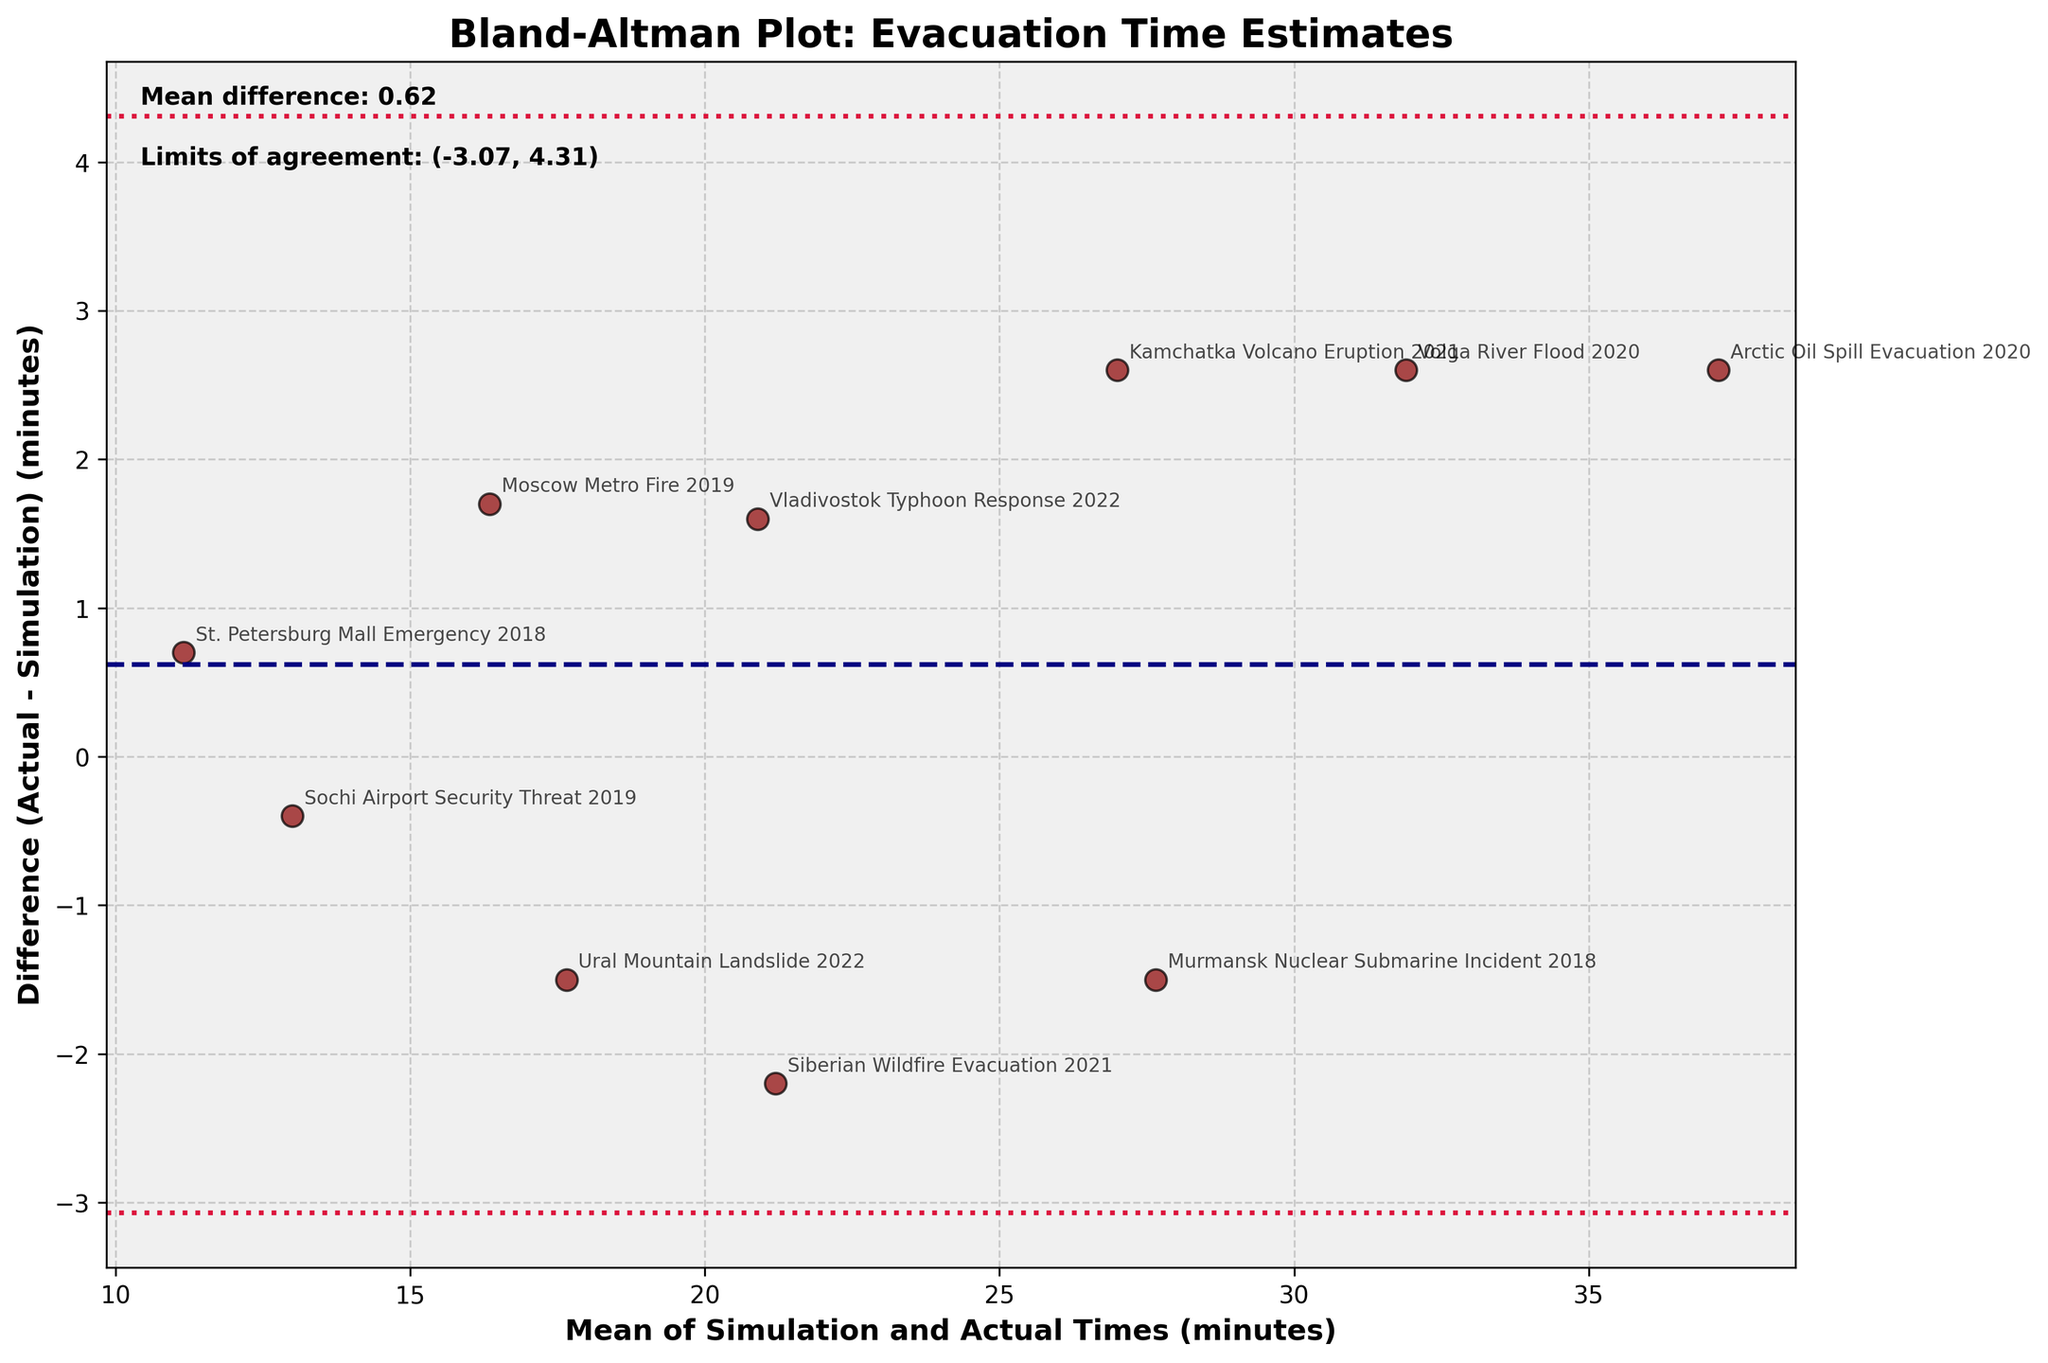What's the title of the figure? The title of a figure is usually found at the top and is bolded to stand out. In this case, the title "Bland-Altman Plot: Evacuation Time Estimates" is clearly displayed at the top of the plot.
Answer: Bland-Altman Plot: Evacuation Time Estimates How many events are plotted in the figure? Count each data point that is plotted in the Bland-Altman plot. Each represents an event. There are 10 data points in the plot.
Answer: 10 What are the x-axis and y-axis labels of the plot? The axis labels are found on the horizontal and vertical axes. The x-axis is labeled "Mean of Simulation and Actual Times (minutes)." The y-axis is labeled "Difference (Actual - Simulation) (minutes)."
Answer: Mean of Simulation and Actual Times (minutes) and Difference (Actual - Simulation) (minutes) What is the mean difference in evacuation times? The mean difference is displayed as text within the plot. It says "Mean difference: 1.28" on the top-left corner of the plot.
Answer: 1.28 Which event has the largest positive difference between actual and simulation times? Look for the data point with the highest position on the y-axis. This is the Arctic Oil Spill Evacuation with a difference of approximately 2.6 minutes.
Answer: Arctic Oil Spill Evacuation What are the limits of agreement shown in the plot? The limits of agreement are displayed as text within the plot. They are noted as "Limits of agreement: (-0.59, 3.16)" in the top-left corner.
Answer: -0.59 and 3.16 Which event shows the closest match between simulation time and actual time? Find the data point that is closest to zero on the y-axis, indicating the smallest difference. This is the Sochi Airport Security Threat with a difference of about 0.4 minutes.
Answer: Sochi Airport Security Threat Between which events do we see the largest range in mean times? Calculate the range by finding the difference between the highest and lowest mean times. The Arctic Oil Spill Evacuation has the highest mean time of 37.2 minutes, and the St. Petersburg Mall Emergency has the lowest mean time of 11.15 minutes. The range is 37.2 - 11.15 = 26.05 minutes.
Answer: Arctic Oil Spill Evacuation and St. Petersburg Mall Emergency Is there any event where the simulation time was substantially lower than the actual time? Look for events where the y-axis value is positive and significantly above zero, indicating higher actual times than simulation times. The Arctic Oil Spill Evacuation and Kamchatka Volcano Eruption show substantial positive differences of about 2.6 and 2.6 minutes, respectively.
Answer: Yes, Arctic Oil Spill Evacuation and Kamchatka Volcano Eruption What does the dotted crimson line in the plot represent? The dotted crimson lines represent the limits of agreement, which indicate the range within which most differences between actual and simulation times fall. These are set at -0.59 and 3.16, respectively.
Answer: Limits of agreement 